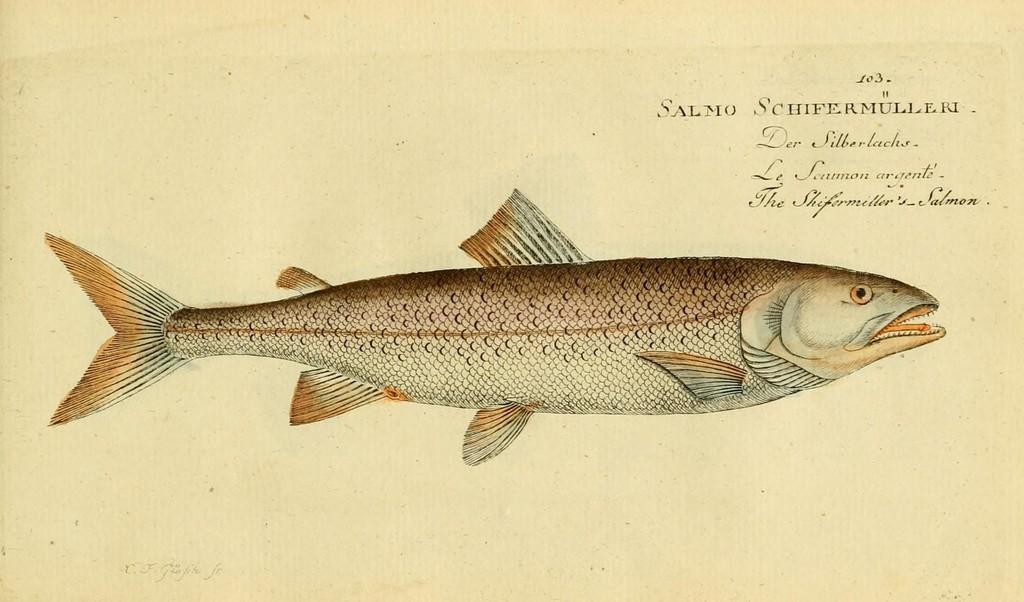What is depicted in the image? There is a sketch of a fish in the image. What is the medium of the sketch? The sketch is on a piece of paper. Where is the text located in the image? The text is on the top right side of the image. What is the color of the background in the image? The background color is cream. What type of pot is visible in the image? There is no pot present in the image; it features a sketch of a fish on a piece of paper. Can you see any mountains in the background of the image? There are no mountains visible in the image; the background color is cream. 